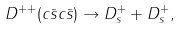<formula> <loc_0><loc_0><loc_500><loc_500>D ^ { + + } ( c \bar { s } c \bar { s } ) \rightarrow D ^ { + } _ { s } + D ^ { + } _ { s } ,</formula> 